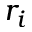Convert formula to latex. <formula><loc_0><loc_0><loc_500><loc_500>r _ { i }</formula> 